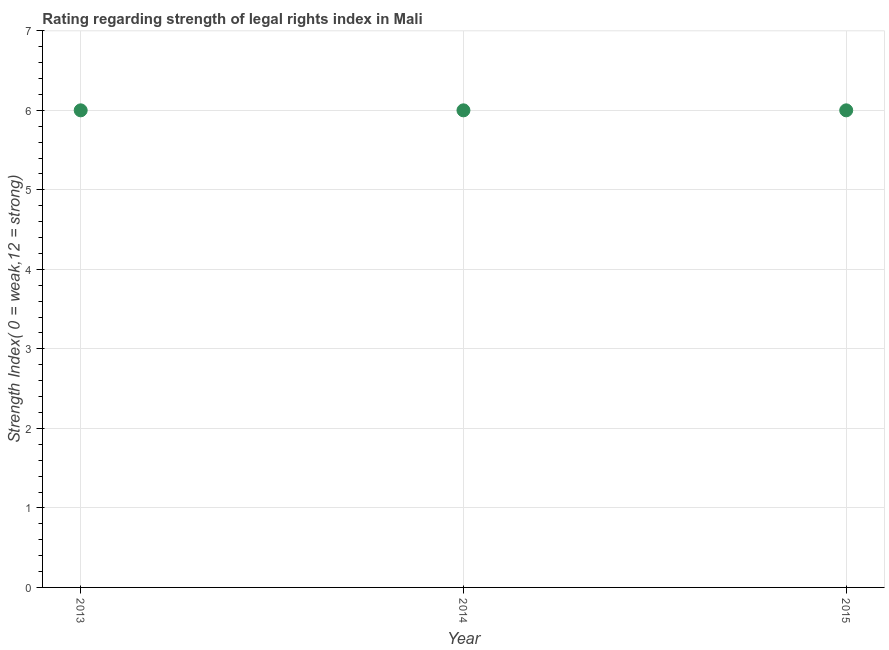What is the strength of legal rights index in 2014?
Your response must be concise. 6. In which year was the strength of legal rights index maximum?
Give a very brief answer. 2013. In which year was the strength of legal rights index minimum?
Make the answer very short. 2013. What is the sum of the strength of legal rights index?
Make the answer very short. 18. What is the difference between the strength of legal rights index in 2014 and 2015?
Make the answer very short. 0. What is the median strength of legal rights index?
Make the answer very short. 6. What is the ratio of the strength of legal rights index in 2014 to that in 2015?
Keep it short and to the point. 1. What is the difference between the highest and the second highest strength of legal rights index?
Keep it short and to the point. 0. In how many years, is the strength of legal rights index greater than the average strength of legal rights index taken over all years?
Keep it short and to the point. 0. Does the strength of legal rights index monotonically increase over the years?
Provide a short and direct response. No. How many years are there in the graph?
Offer a very short reply. 3. What is the difference between two consecutive major ticks on the Y-axis?
Give a very brief answer. 1. Are the values on the major ticks of Y-axis written in scientific E-notation?
Offer a terse response. No. Does the graph contain grids?
Provide a short and direct response. Yes. What is the title of the graph?
Your response must be concise. Rating regarding strength of legal rights index in Mali. What is the label or title of the Y-axis?
Your answer should be compact. Strength Index( 0 = weak,12 = strong). What is the Strength Index( 0 = weak,12 = strong) in 2013?
Provide a short and direct response. 6. What is the Strength Index( 0 = weak,12 = strong) in 2014?
Keep it short and to the point. 6. What is the Strength Index( 0 = weak,12 = strong) in 2015?
Your answer should be very brief. 6. What is the difference between the Strength Index( 0 = weak,12 = strong) in 2013 and 2014?
Provide a short and direct response. 0. What is the difference between the Strength Index( 0 = weak,12 = strong) in 2014 and 2015?
Provide a succinct answer. 0. What is the ratio of the Strength Index( 0 = weak,12 = strong) in 2013 to that in 2015?
Make the answer very short. 1. What is the ratio of the Strength Index( 0 = weak,12 = strong) in 2014 to that in 2015?
Ensure brevity in your answer.  1. 